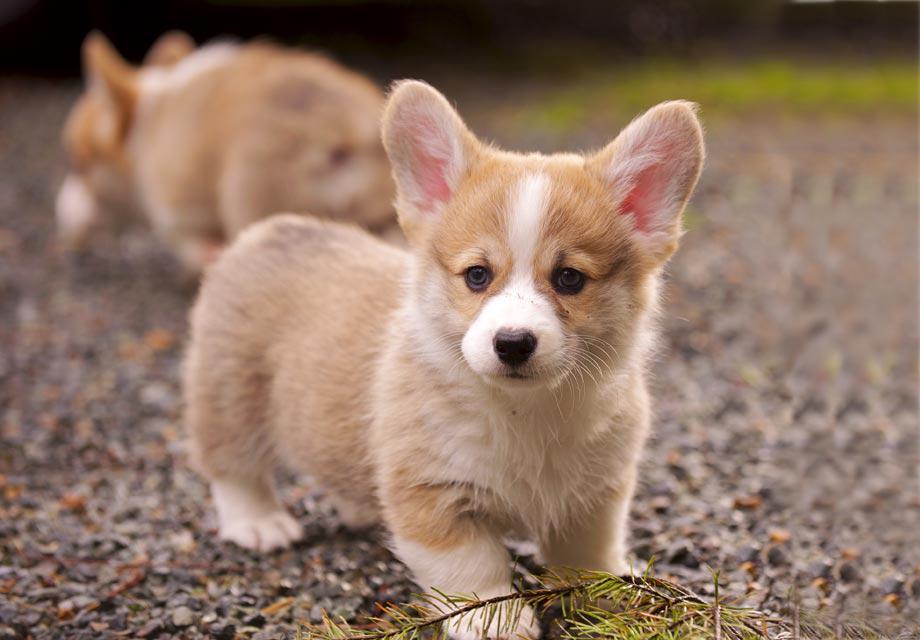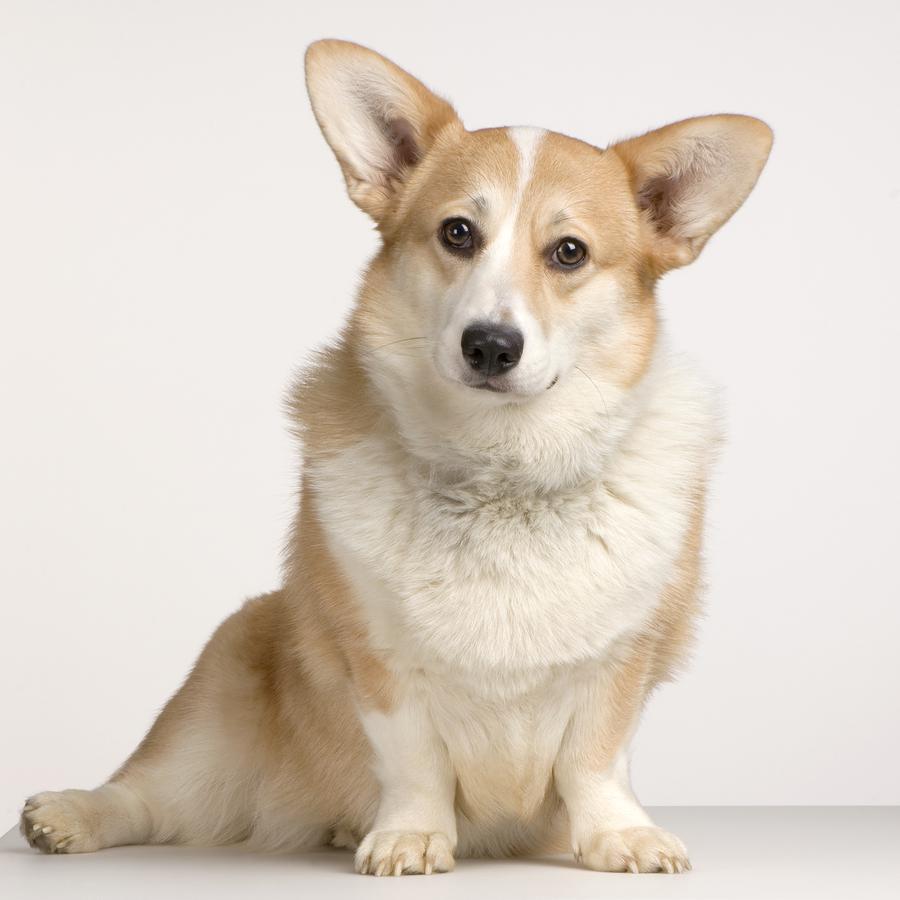The first image is the image on the left, the second image is the image on the right. Considering the images on both sides, is "At least one dog has its mouth completely closed." valid? Answer yes or no. Yes. The first image is the image on the left, the second image is the image on the right. Examine the images to the left and right. Is the description "Right image shows one short-legged dog standing outdoors." accurate? Answer yes or no. No. 